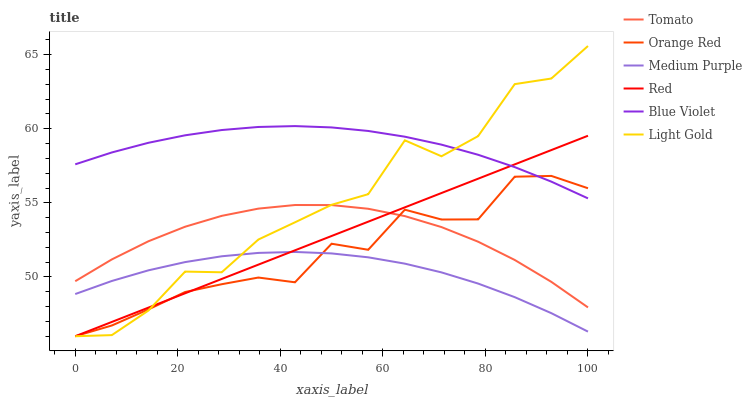Does Medium Purple have the minimum area under the curve?
Answer yes or no. Yes. Does Blue Violet have the maximum area under the curve?
Answer yes or no. Yes. Does Red have the minimum area under the curve?
Answer yes or no. No. Does Red have the maximum area under the curve?
Answer yes or no. No. Is Red the smoothest?
Answer yes or no. Yes. Is Light Gold the roughest?
Answer yes or no. Yes. Is Medium Purple the smoothest?
Answer yes or no. No. Is Medium Purple the roughest?
Answer yes or no. No. Does Medium Purple have the lowest value?
Answer yes or no. No. Does Light Gold have the highest value?
Answer yes or no. Yes. Does Red have the highest value?
Answer yes or no. No. Is Medium Purple less than Tomato?
Answer yes or no. Yes. Is Blue Violet greater than Medium Purple?
Answer yes or no. Yes. Does Red intersect Medium Purple?
Answer yes or no. Yes. Is Red less than Medium Purple?
Answer yes or no. No. Is Red greater than Medium Purple?
Answer yes or no. No. Does Medium Purple intersect Tomato?
Answer yes or no. No. 